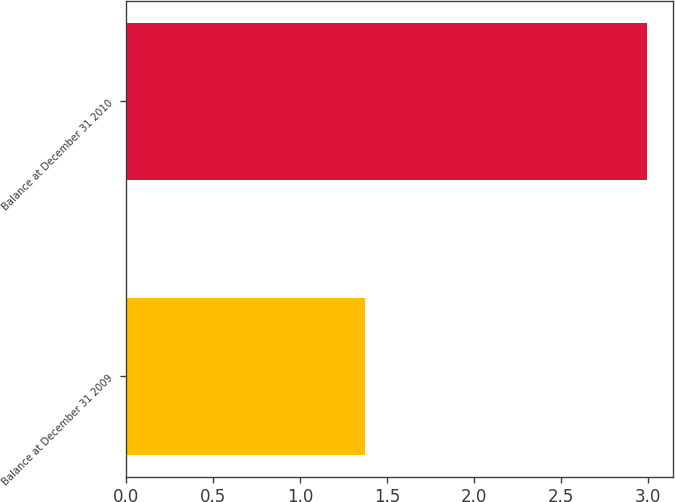<chart> <loc_0><loc_0><loc_500><loc_500><bar_chart><fcel>Balance at December 31 2009<fcel>Balance at December 31 2010<nl><fcel>1.37<fcel>2.99<nl></chart> 